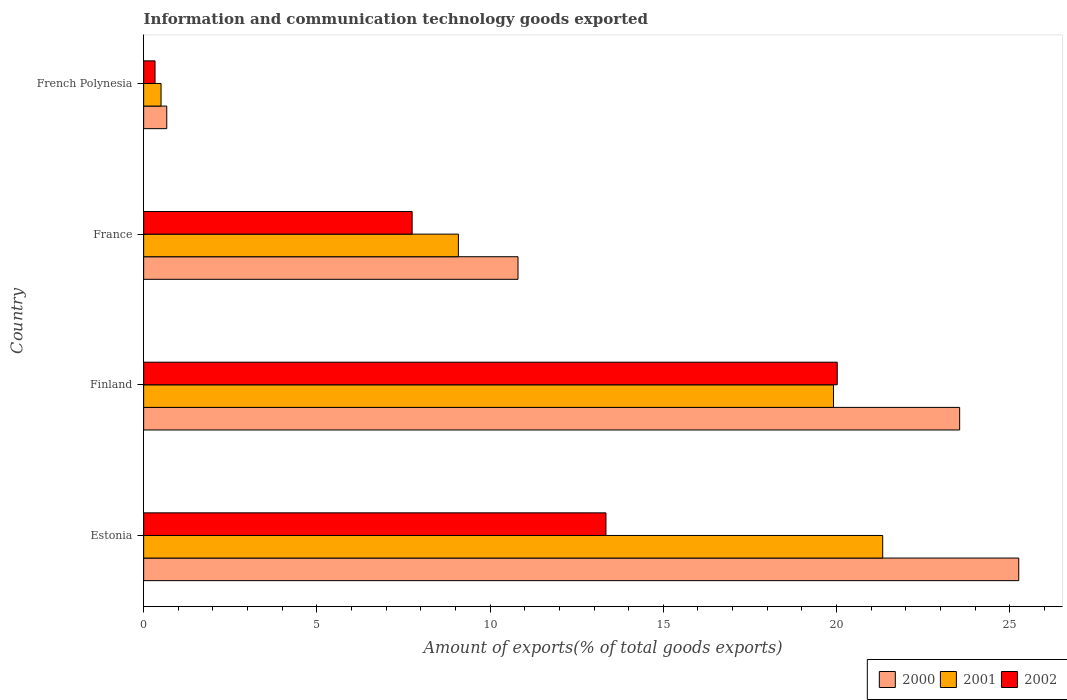How many groups of bars are there?
Provide a short and direct response. 4. Are the number of bars per tick equal to the number of legend labels?
Your response must be concise. Yes. What is the amount of goods exported in 2001 in France?
Your response must be concise. 9.08. Across all countries, what is the maximum amount of goods exported in 2002?
Provide a succinct answer. 20.02. Across all countries, what is the minimum amount of goods exported in 2002?
Give a very brief answer. 0.33. In which country was the amount of goods exported in 2000 maximum?
Offer a terse response. Estonia. In which country was the amount of goods exported in 2000 minimum?
Offer a terse response. French Polynesia. What is the total amount of goods exported in 2002 in the graph?
Provide a succinct answer. 41.44. What is the difference between the amount of goods exported in 2000 in Estonia and that in French Polynesia?
Ensure brevity in your answer.  24.59. What is the difference between the amount of goods exported in 2002 in French Polynesia and the amount of goods exported in 2001 in France?
Make the answer very short. -8.76. What is the average amount of goods exported in 2002 per country?
Provide a succinct answer. 10.36. What is the difference between the amount of goods exported in 2000 and amount of goods exported in 2002 in Estonia?
Give a very brief answer. 11.91. In how many countries, is the amount of goods exported in 2001 greater than 14 %?
Your answer should be compact. 2. What is the ratio of the amount of goods exported in 2001 in Estonia to that in France?
Ensure brevity in your answer.  2.35. What is the difference between the highest and the second highest amount of goods exported in 2001?
Make the answer very short. 1.42. What is the difference between the highest and the lowest amount of goods exported in 2000?
Make the answer very short. 24.59. In how many countries, is the amount of goods exported in 2000 greater than the average amount of goods exported in 2000 taken over all countries?
Offer a very short reply. 2. What does the 2nd bar from the top in Finland represents?
Keep it short and to the point. 2001. What does the 1st bar from the bottom in France represents?
Your answer should be compact. 2000. How many bars are there?
Keep it short and to the point. 12. Does the graph contain grids?
Your response must be concise. No. Where does the legend appear in the graph?
Provide a succinct answer. Bottom right. How many legend labels are there?
Provide a succinct answer. 3. What is the title of the graph?
Ensure brevity in your answer.  Information and communication technology goods exported. What is the label or title of the X-axis?
Provide a short and direct response. Amount of exports(% of total goods exports). What is the Amount of exports(% of total goods exports) in 2000 in Estonia?
Provide a succinct answer. 25.26. What is the Amount of exports(% of total goods exports) of 2001 in Estonia?
Offer a terse response. 21.33. What is the Amount of exports(% of total goods exports) in 2002 in Estonia?
Your answer should be very brief. 13.34. What is the Amount of exports(% of total goods exports) in 2000 in Finland?
Your answer should be compact. 23.55. What is the Amount of exports(% of total goods exports) in 2001 in Finland?
Offer a very short reply. 19.91. What is the Amount of exports(% of total goods exports) in 2002 in Finland?
Ensure brevity in your answer.  20.02. What is the Amount of exports(% of total goods exports) in 2000 in France?
Your answer should be very brief. 10.81. What is the Amount of exports(% of total goods exports) of 2001 in France?
Offer a terse response. 9.08. What is the Amount of exports(% of total goods exports) in 2002 in France?
Provide a short and direct response. 7.75. What is the Amount of exports(% of total goods exports) of 2000 in French Polynesia?
Offer a very short reply. 0.67. What is the Amount of exports(% of total goods exports) of 2001 in French Polynesia?
Ensure brevity in your answer.  0.5. What is the Amount of exports(% of total goods exports) in 2002 in French Polynesia?
Provide a succinct answer. 0.33. Across all countries, what is the maximum Amount of exports(% of total goods exports) of 2000?
Give a very brief answer. 25.26. Across all countries, what is the maximum Amount of exports(% of total goods exports) in 2001?
Make the answer very short. 21.33. Across all countries, what is the maximum Amount of exports(% of total goods exports) of 2002?
Your response must be concise. 20.02. Across all countries, what is the minimum Amount of exports(% of total goods exports) of 2000?
Ensure brevity in your answer.  0.67. Across all countries, what is the minimum Amount of exports(% of total goods exports) in 2001?
Provide a short and direct response. 0.5. Across all countries, what is the minimum Amount of exports(% of total goods exports) of 2002?
Give a very brief answer. 0.33. What is the total Amount of exports(% of total goods exports) in 2000 in the graph?
Keep it short and to the point. 60.29. What is the total Amount of exports(% of total goods exports) of 2001 in the graph?
Your answer should be compact. 50.83. What is the total Amount of exports(% of total goods exports) in 2002 in the graph?
Provide a short and direct response. 41.44. What is the difference between the Amount of exports(% of total goods exports) in 2000 in Estonia and that in Finland?
Your answer should be compact. 1.71. What is the difference between the Amount of exports(% of total goods exports) of 2001 in Estonia and that in Finland?
Keep it short and to the point. 1.42. What is the difference between the Amount of exports(% of total goods exports) in 2002 in Estonia and that in Finland?
Keep it short and to the point. -6.68. What is the difference between the Amount of exports(% of total goods exports) of 2000 in Estonia and that in France?
Your answer should be compact. 14.45. What is the difference between the Amount of exports(% of total goods exports) in 2001 in Estonia and that in France?
Make the answer very short. 12.25. What is the difference between the Amount of exports(% of total goods exports) in 2002 in Estonia and that in France?
Offer a terse response. 5.59. What is the difference between the Amount of exports(% of total goods exports) in 2000 in Estonia and that in French Polynesia?
Your response must be concise. 24.59. What is the difference between the Amount of exports(% of total goods exports) in 2001 in Estonia and that in French Polynesia?
Keep it short and to the point. 20.83. What is the difference between the Amount of exports(% of total goods exports) of 2002 in Estonia and that in French Polynesia?
Provide a succinct answer. 13.02. What is the difference between the Amount of exports(% of total goods exports) in 2000 in Finland and that in France?
Make the answer very short. 12.75. What is the difference between the Amount of exports(% of total goods exports) in 2001 in Finland and that in France?
Keep it short and to the point. 10.83. What is the difference between the Amount of exports(% of total goods exports) of 2002 in Finland and that in France?
Make the answer very short. 12.27. What is the difference between the Amount of exports(% of total goods exports) in 2000 in Finland and that in French Polynesia?
Your answer should be very brief. 22.89. What is the difference between the Amount of exports(% of total goods exports) in 2001 in Finland and that in French Polynesia?
Give a very brief answer. 19.41. What is the difference between the Amount of exports(% of total goods exports) in 2002 in Finland and that in French Polynesia?
Provide a succinct answer. 19.69. What is the difference between the Amount of exports(% of total goods exports) of 2000 in France and that in French Polynesia?
Offer a terse response. 10.14. What is the difference between the Amount of exports(% of total goods exports) in 2001 in France and that in French Polynesia?
Offer a very short reply. 8.58. What is the difference between the Amount of exports(% of total goods exports) in 2002 in France and that in French Polynesia?
Give a very brief answer. 7.42. What is the difference between the Amount of exports(% of total goods exports) in 2000 in Estonia and the Amount of exports(% of total goods exports) in 2001 in Finland?
Your answer should be compact. 5.35. What is the difference between the Amount of exports(% of total goods exports) in 2000 in Estonia and the Amount of exports(% of total goods exports) in 2002 in Finland?
Offer a very short reply. 5.24. What is the difference between the Amount of exports(% of total goods exports) in 2001 in Estonia and the Amount of exports(% of total goods exports) in 2002 in Finland?
Your answer should be compact. 1.31. What is the difference between the Amount of exports(% of total goods exports) of 2000 in Estonia and the Amount of exports(% of total goods exports) of 2001 in France?
Offer a very short reply. 16.17. What is the difference between the Amount of exports(% of total goods exports) in 2000 in Estonia and the Amount of exports(% of total goods exports) in 2002 in France?
Your response must be concise. 17.51. What is the difference between the Amount of exports(% of total goods exports) in 2001 in Estonia and the Amount of exports(% of total goods exports) in 2002 in France?
Offer a terse response. 13.58. What is the difference between the Amount of exports(% of total goods exports) in 2000 in Estonia and the Amount of exports(% of total goods exports) in 2001 in French Polynesia?
Your answer should be very brief. 24.76. What is the difference between the Amount of exports(% of total goods exports) of 2000 in Estonia and the Amount of exports(% of total goods exports) of 2002 in French Polynesia?
Your answer should be very brief. 24.93. What is the difference between the Amount of exports(% of total goods exports) of 2001 in Estonia and the Amount of exports(% of total goods exports) of 2002 in French Polynesia?
Ensure brevity in your answer.  21. What is the difference between the Amount of exports(% of total goods exports) of 2000 in Finland and the Amount of exports(% of total goods exports) of 2001 in France?
Your answer should be very brief. 14.47. What is the difference between the Amount of exports(% of total goods exports) of 2000 in Finland and the Amount of exports(% of total goods exports) of 2002 in France?
Make the answer very short. 15.8. What is the difference between the Amount of exports(% of total goods exports) in 2001 in Finland and the Amount of exports(% of total goods exports) in 2002 in France?
Give a very brief answer. 12.16. What is the difference between the Amount of exports(% of total goods exports) of 2000 in Finland and the Amount of exports(% of total goods exports) of 2001 in French Polynesia?
Your answer should be very brief. 23.05. What is the difference between the Amount of exports(% of total goods exports) of 2000 in Finland and the Amount of exports(% of total goods exports) of 2002 in French Polynesia?
Your response must be concise. 23.23. What is the difference between the Amount of exports(% of total goods exports) in 2001 in Finland and the Amount of exports(% of total goods exports) in 2002 in French Polynesia?
Your answer should be very brief. 19.58. What is the difference between the Amount of exports(% of total goods exports) of 2000 in France and the Amount of exports(% of total goods exports) of 2001 in French Polynesia?
Offer a very short reply. 10.3. What is the difference between the Amount of exports(% of total goods exports) of 2000 in France and the Amount of exports(% of total goods exports) of 2002 in French Polynesia?
Your response must be concise. 10.48. What is the difference between the Amount of exports(% of total goods exports) of 2001 in France and the Amount of exports(% of total goods exports) of 2002 in French Polynesia?
Keep it short and to the point. 8.76. What is the average Amount of exports(% of total goods exports) in 2000 per country?
Give a very brief answer. 15.07. What is the average Amount of exports(% of total goods exports) of 2001 per country?
Provide a succinct answer. 12.71. What is the average Amount of exports(% of total goods exports) of 2002 per country?
Provide a succinct answer. 10.36. What is the difference between the Amount of exports(% of total goods exports) in 2000 and Amount of exports(% of total goods exports) in 2001 in Estonia?
Provide a short and direct response. 3.93. What is the difference between the Amount of exports(% of total goods exports) of 2000 and Amount of exports(% of total goods exports) of 2002 in Estonia?
Your answer should be compact. 11.91. What is the difference between the Amount of exports(% of total goods exports) of 2001 and Amount of exports(% of total goods exports) of 2002 in Estonia?
Your answer should be very brief. 7.99. What is the difference between the Amount of exports(% of total goods exports) of 2000 and Amount of exports(% of total goods exports) of 2001 in Finland?
Your response must be concise. 3.64. What is the difference between the Amount of exports(% of total goods exports) in 2000 and Amount of exports(% of total goods exports) in 2002 in Finland?
Ensure brevity in your answer.  3.53. What is the difference between the Amount of exports(% of total goods exports) in 2001 and Amount of exports(% of total goods exports) in 2002 in Finland?
Your answer should be compact. -0.11. What is the difference between the Amount of exports(% of total goods exports) in 2000 and Amount of exports(% of total goods exports) in 2001 in France?
Ensure brevity in your answer.  1.72. What is the difference between the Amount of exports(% of total goods exports) in 2000 and Amount of exports(% of total goods exports) in 2002 in France?
Your answer should be very brief. 3.06. What is the difference between the Amount of exports(% of total goods exports) of 2001 and Amount of exports(% of total goods exports) of 2002 in France?
Make the answer very short. 1.33. What is the difference between the Amount of exports(% of total goods exports) in 2000 and Amount of exports(% of total goods exports) in 2001 in French Polynesia?
Keep it short and to the point. 0.17. What is the difference between the Amount of exports(% of total goods exports) of 2000 and Amount of exports(% of total goods exports) of 2002 in French Polynesia?
Offer a very short reply. 0.34. What is the difference between the Amount of exports(% of total goods exports) in 2001 and Amount of exports(% of total goods exports) in 2002 in French Polynesia?
Your answer should be compact. 0.17. What is the ratio of the Amount of exports(% of total goods exports) in 2000 in Estonia to that in Finland?
Provide a short and direct response. 1.07. What is the ratio of the Amount of exports(% of total goods exports) of 2001 in Estonia to that in Finland?
Offer a very short reply. 1.07. What is the ratio of the Amount of exports(% of total goods exports) of 2002 in Estonia to that in Finland?
Ensure brevity in your answer.  0.67. What is the ratio of the Amount of exports(% of total goods exports) in 2000 in Estonia to that in France?
Keep it short and to the point. 2.34. What is the ratio of the Amount of exports(% of total goods exports) of 2001 in Estonia to that in France?
Provide a short and direct response. 2.35. What is the ratio of the Amount of exports(% of total goods exports) in 2002 in Estonia to that in France?
Give a very brief answer. 1.72. What is the ratio of the Amount of exports(% of total goods exports) in 2000 in Estonia to that in French Polynesia?
Give a very brief answer. 37.86. What is the ratio of the Amount of exports(% of total goods exports) in 2001 in Estonia to that in French Polynesia?
Your response must be concise. 42.49. What is the ratio of the Amount of exports(% of total goods exports) in 2002 in Estonia to that in French Polynesia?
Your answer should be compact. 40.63. What is the ratio of the Amount of exports(% of total goods exports) in 2000 in Finland to that in France?
Make the answer very short. 2.18. What is the ratio of the Amount of exports(% of total goods exports) in 2001 in Finland to that in France?
Give a very brief answer. 2.19. What is the ratio of the Amount of exports(% of total goods exports) in 2002 in Finland to that in France?
Give a very brief answer. 2.58. What is the ratio of the Amount of exports(% of total goods exports) in 2000 in Finland to that in French Polynesia?
Give a very brief answer. 35.31. What is the ratio of the Amount of exports(% of total goods exports) of 2001 in Finland to that in French Polynesia?
Keep it short and to the point. 39.66. What is the ratio of the Amount of exports(% of total goods exports) in 2002 in Finland to that in French Polynesia?
Your response must be concise. 60.96. What is the ratio of the Amount of exports(% of total goods exports) of 2000 in France to that in French Polynesia?
Your answer should be very brief. 16.2. What is the ratio of the Amount of exports(% of total goods exports) in 2001 in France to that in French Polynesia?
Make the answer very short. 18.09. What is the ratio of the Amount of exports(% of total goods exports) of 2002 in France to that in French Polynesia?
Keep it short and to the point. 23.6. What is the difference between the highest and the second highest Amount of exports(% of total goods exports) in 2000?
Offer a terse response. 1.71. What is the difference between the highest and the second highest Amount of exports(% of total goods exports) in 2001?
Your answer should be compact. 1.42. What is the difference between the highest and the second highest Amount of exports(% of total goods exports) in 2002?
Your response must be concise. 6.68. What is the difference between the highest and the lowest Amount of exports(% of total goods exports) in 2000?
Your answer should be compact. 24.59. What is the difference between the highest and the lowest Amount of exports(% of total goods exports) of 2001?
Your answer should be compact. 20.83. What is the difference between the highest and the lowest Amount of exports(% of total goods exports) of 2002?
Ensure brevity in your answer.  19.69. 